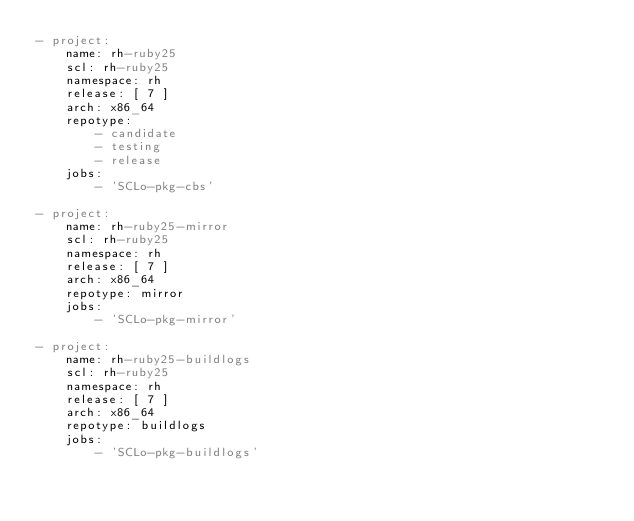<code> <loc_0><loc_0><loc_500><loc_500><_YAML_>- project:
    name: rh-ruby25
    scl: rh-ruby25
    namespace: rh
    release: [ 7 ]
    arch: x86_64
    repotype:
        - candidate
        - testing
        - release
    jobs:
        - 'SCLo-pkg-cbs'

- project:
    name: rh-ruby25-mirror
    scl: rh-ruby25
    namespace: rh
    release: [ 7 ]
    arch: x86_64
    repotype: mirror
    jobs:
        - 'SCLo-pkg-mirror'

- project:
    name: rh-ruby25-buildlogs
    scl: rh-ruby25
    namespace: rh
    release: [ 7 ]
    arch: x86_64
    repotype: buildlogs
    jobs:
        - 'SCLo-pkg-buildlogs'
</code> 